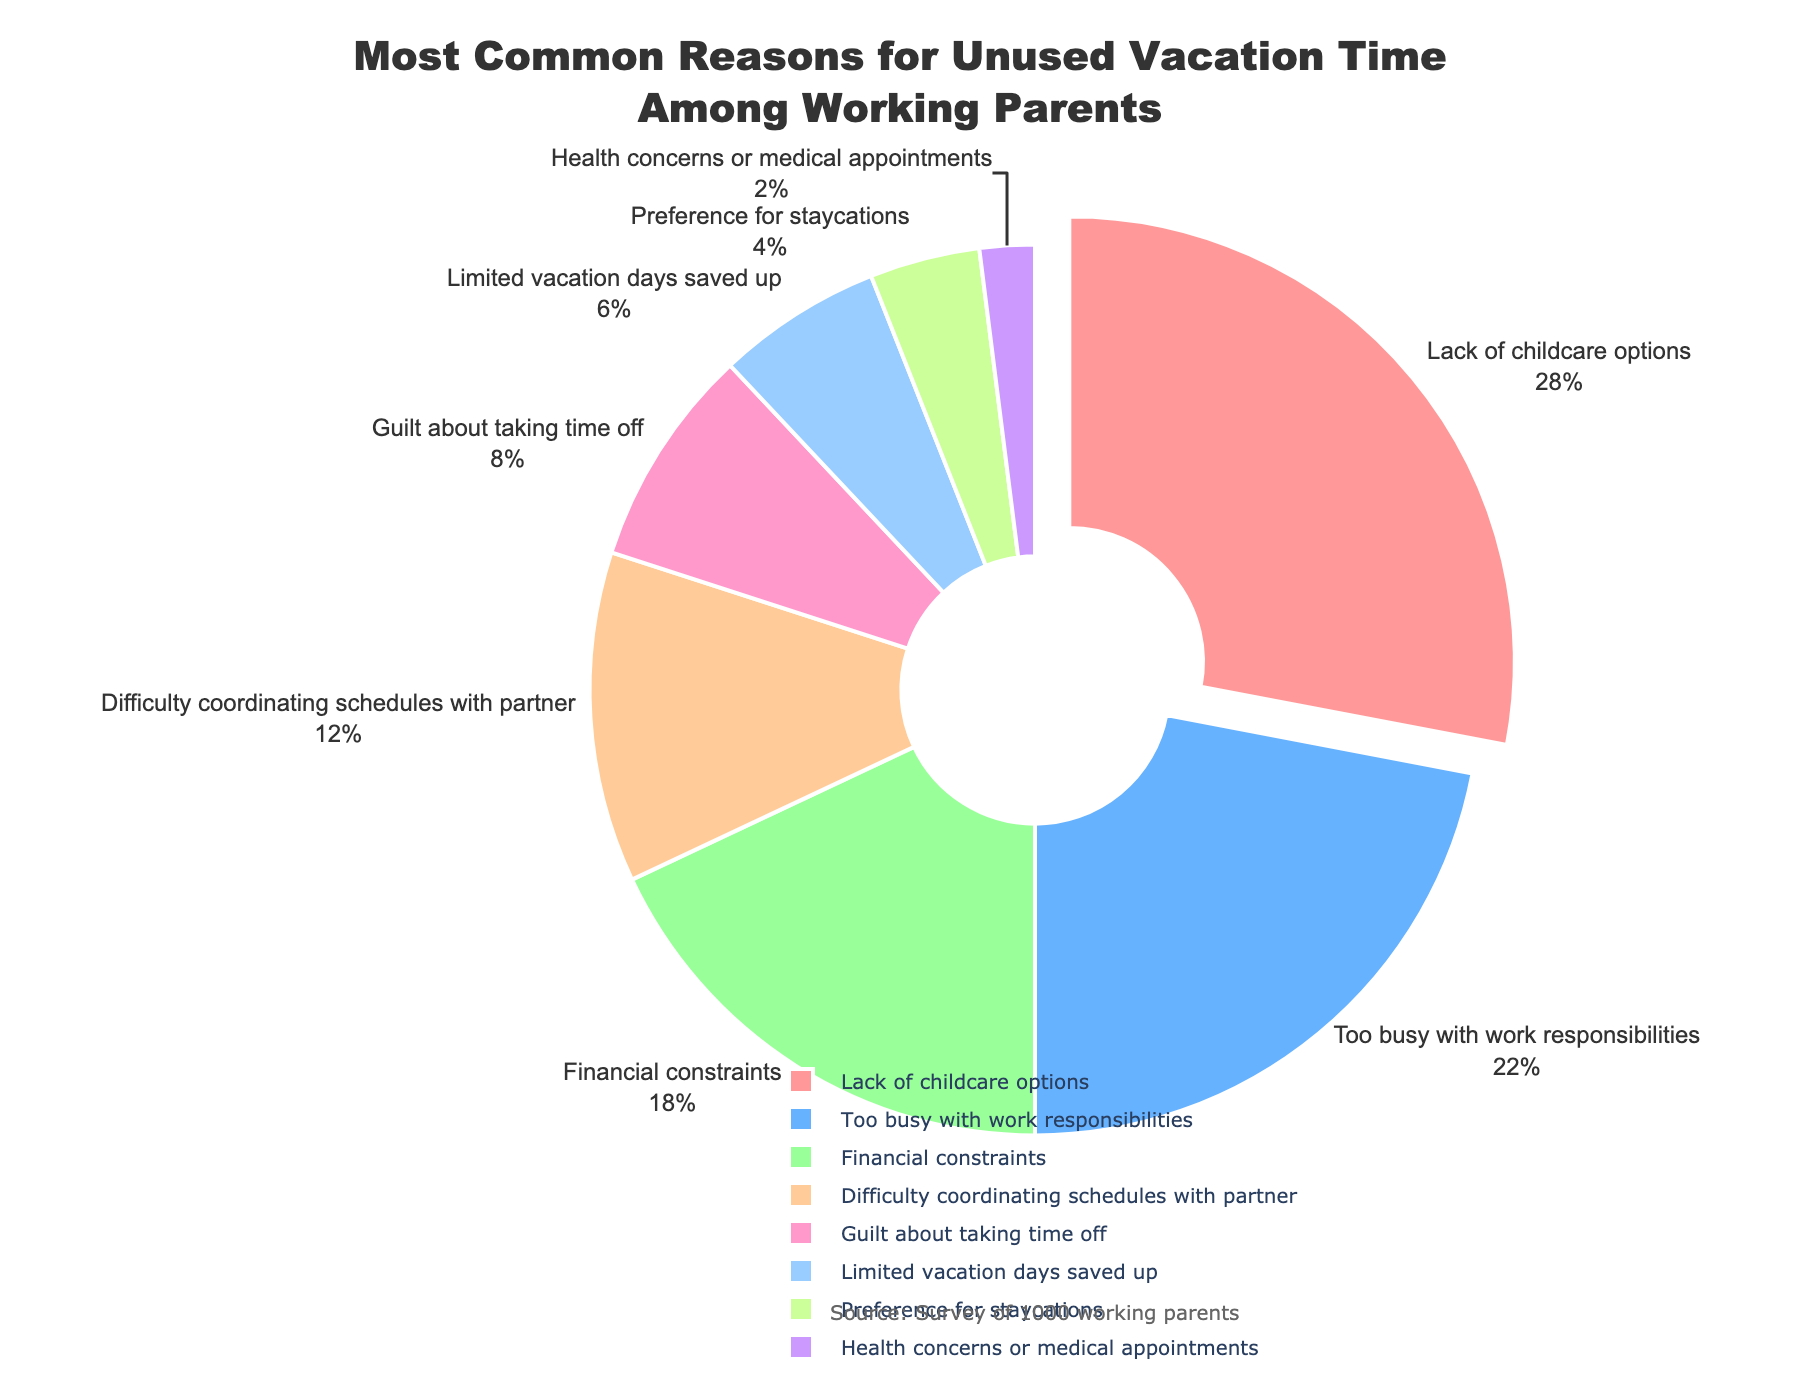Which reason is the most common for vacation time not being used? The most common reason can be determined by looking at the segment that is pulled out from the pie chart and has the largest percentage.
Answer: Lack of childcare options Which reason is the least common for vacation time not being used? The least common reason can be identified by finding the smallest segment in the pie chart, which also shows the smallest percentage.
Answer: Health concerns or medical appointments What is the combined percentage of parents who do not use vacation time due to being too busy with work responsibilities and financial constraints? To find the combined percentage, add the percentages attributed to each reason: 22% (too busy with work responsibilities) + 18% (financial constraints).
Answer: 40% How much more common is the lack of childcare options compared to guilt about taking time off? Subtract the percentage of parents citing guilt about taking time off (8%) from those citing lack of childcare options (28%).
Answer: 20% What percentage difference exists between parents who prefer staycations and those who have limited vacation days saved up? Subtract the percentage for preference for staycations (4%) from the percentage for limited vacation days saved up (6%).
Answer: 2% Which reasons have a percentage equal to or greater than 10%? Identify all segments in the pie chart with percentages equal to or greater than 10%. These segments are "Lack of childcare options" (28%), "Too busy with work responsibilities" (22%), and "Difficulty coordinating schedules with partner" (12%).
Answer: Lack of childcare options, Too busy with work responsibilities, Difficulty coordinating schedules with partner What is the total percentage for parents who do not use vacation time due to reasons related to external constraints (lack of childcare options, financial constraints, and limited vacation days)? Add the percentages for each external constraint-related reason: 28% (lack of childcare options) + 18% (financial constraints) + 6% (limited vacation days).
Answer: 52% Is it more common for parents to not use vacation time due to financial constraints or guilt about taking time off, and by how much? Compare the two percentages: financial constraints (18%) versus guilt about taking time off (8%). Calculate the difference: 18% - 8%.
Answer: Financial constraints by 10% Which color represents the reason ‘preference for staycations’ on the pie chart? Locate the segment labeled 'Preference for staycations' and note the color used.
Answer: Green What is the average percentage for reasons that fall between 5% and 15%? Identify the reasons within that percentage range: "Difficulty coordinating schedules with partner" (12%) and "Guilt about taking time off" (8%). Calculate the average: (12% + 8%) / 2.
Answer: 10% 